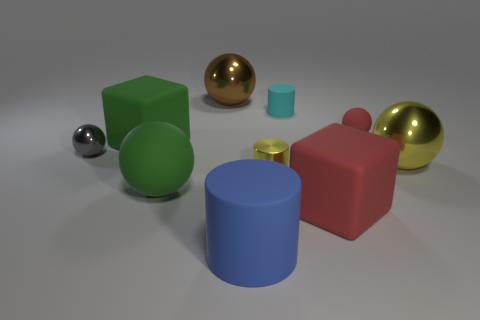Are there any gray metallic spheres that have the same size as the green ball?
Your answer should be compact. No. There is a yellow ball that is the same size as the brown shiny sphere; what material is it?
Offer a very short reply. Metal. What size is the red rubber object in front of the green thing that is in front of the large yellow metallic sphere?
Your answer should be very brief. Large. There is a metal thing left of the green rubber ball; is it the same size as the small cyan cylinder?
Offer a very short reply. Yes. Is the number of tiny rubber objects behind the small red matte ball greater than the number of tiny shiny cylinders that are behind the small cyan cylinder?
Provide a short and direct response. Yes. What shape is the rubber thing that is both on the right side of the big cylinder and in front of the gray ball?
Provide a succinct answer. Cube. There is a red matte object that is behind the large red rubber cube; what shape is it?
Your response must be concise. Sphere. How big is the matte cube that is in front of the shiny object in front of the large shiny object to the right of the large red rubber cube?
Make the answer very short. Large. Is the shape of the big red object the same as the blue rubber object?
Your response must be concise. No. How big is the metal ball that is left of the tiny cyan matte object and in front of the small cyan rubber cylinder?
Make the answer very short. Small. 